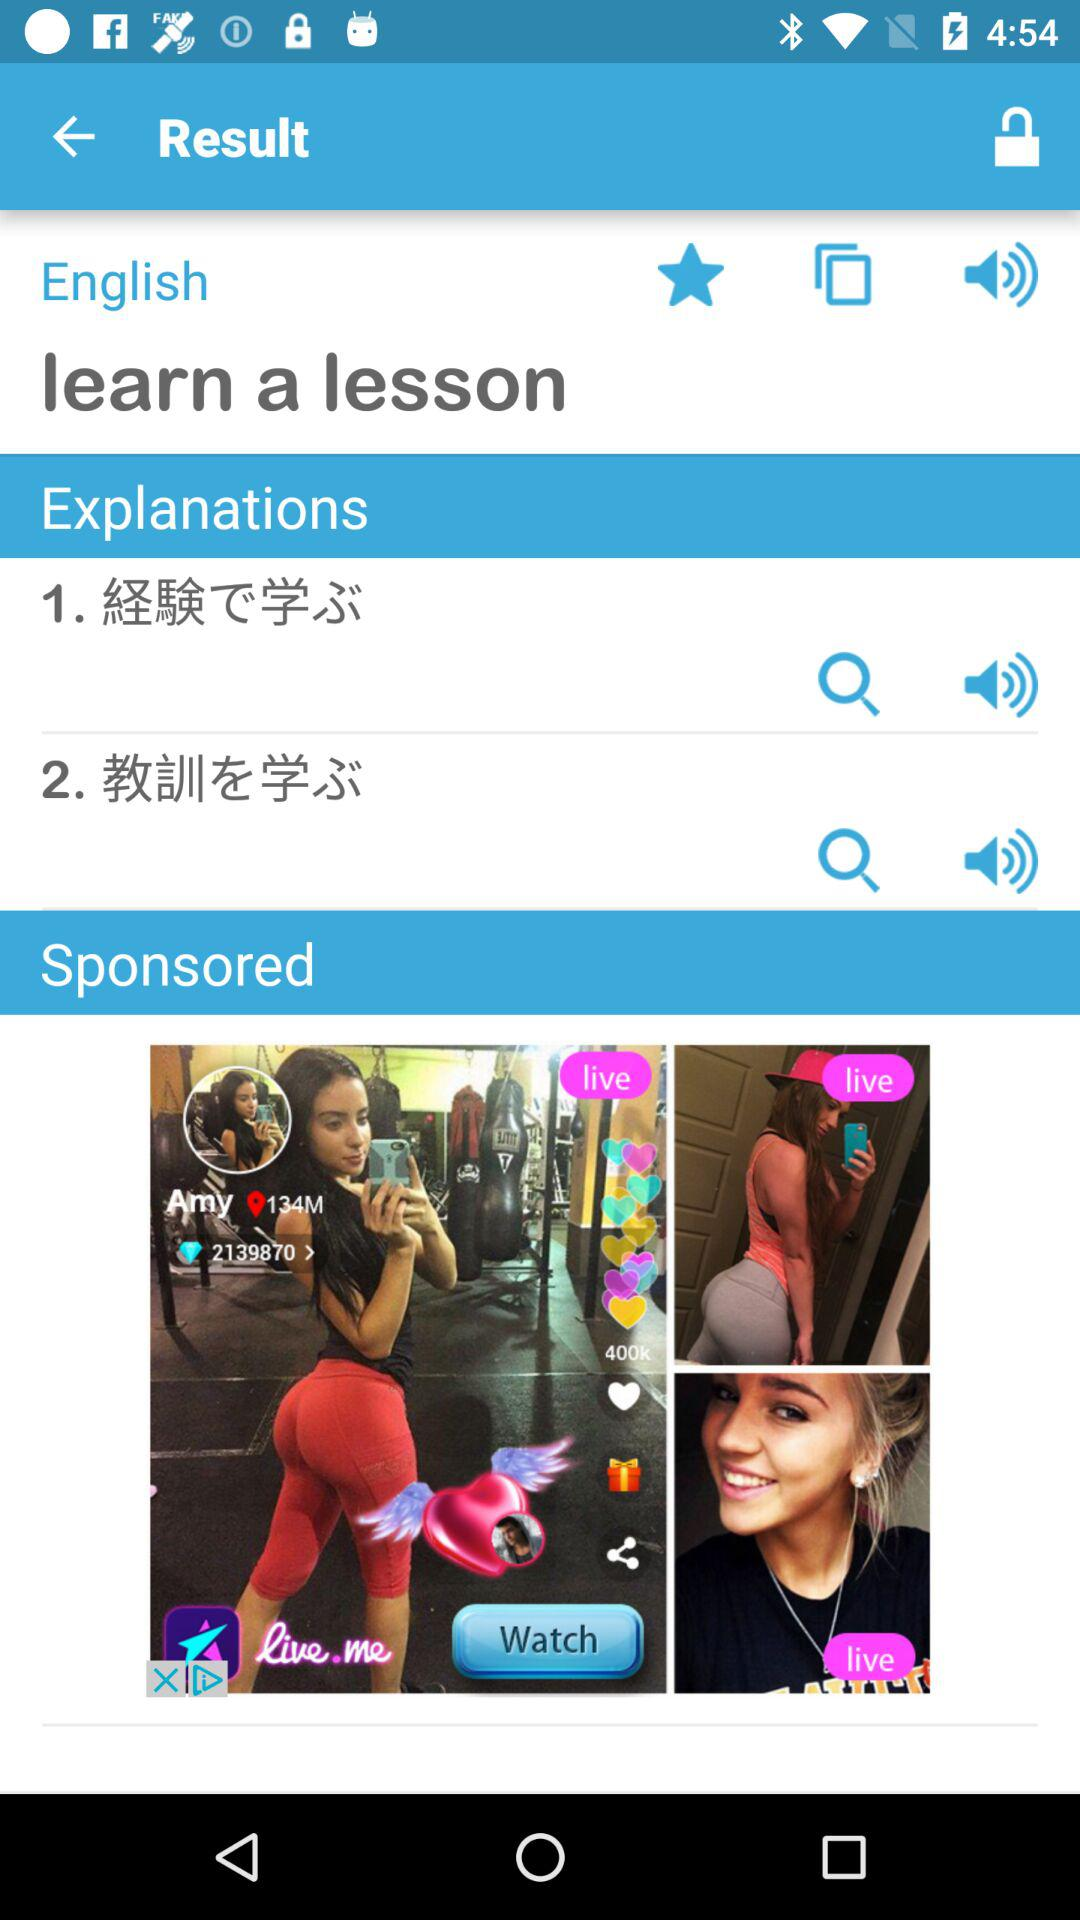How many explanations are there?
Answer the question using a single word or phrase. 2 